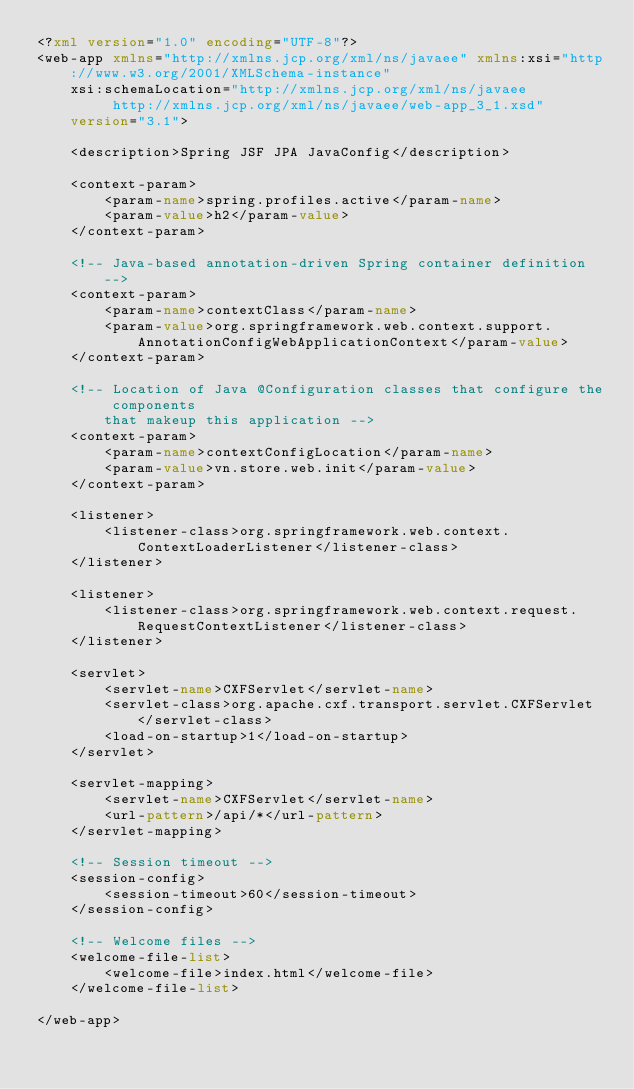Convert code to text. <code><loc_0><loc_0><loc_500><loc_500><_XML_><?xml version="1.0" encoding="UTF-8"?>
<web-app xmlns="http://xmlns.jcp.org/xml/ns/javaee" xmlns:xsi="http://www.w3.org/2001/XMLSchema-instance"
	xsi:schemaLocation="http://xmlns.jcp.org/xml/ns/javaee 
		 http://xmlns.jcp.org/xml/ns/javaee/web-app_3_1.xsd"
	version="3.1">

	<description>Spring JSF JPA JavaConfig</description>

	<context-param>
		<param-name>spring.profiles.active</param-name>
		<param-value>h2</param-value>
	</context-param>

	<!-- Java-based annotation-driven Spring container definition -->
	<context-param>
		<param-name>contextClass</param-name>
		<param-value>org.springframework.web.context.support.AnnotationConfigWebApplicationContext</param-value>
	</context-param>

	<!-- Location of Java @Configuration classes that configure the components 
		that makeup this application -->
	<context-param>
		<param-name>contextConfigLocation</param-name>
		<param-value>vn.store.web.init</param-value>
	</context-param>

	<listener>
		<listener-class>org.springframework.web.context.ContextLoaderListener</listener-class>
	</listener>

	<listener>
		<listener-class>org.springframework.web.context.request.RequestContextListener</listener-class>
	</listener>

	<servlet>
		<servlet-name>CXFServlet</servlet-name>
		<servlet-class>org.apache.cxf.transport.servlet.CXFServlet</servlet-class>
		<load-on-startup>1</load-on-startup>
	</servlet>

	<servlet-mapping>
		<servlet-name>CXFServlet</servlet-name>
		<url-pattern>/api/*</url-pattern>
	</servlet-mapping>
	
	<!-- Session timeout -->
	<session-config>
		<session-timeout>60</session-timeout>
	</session-config>

	<!-- Welcome files -->
	<welcome-file-list>
		<welcome-file>index.html</welcome-file>
	</welcome-file-list>

</web-app></code> 